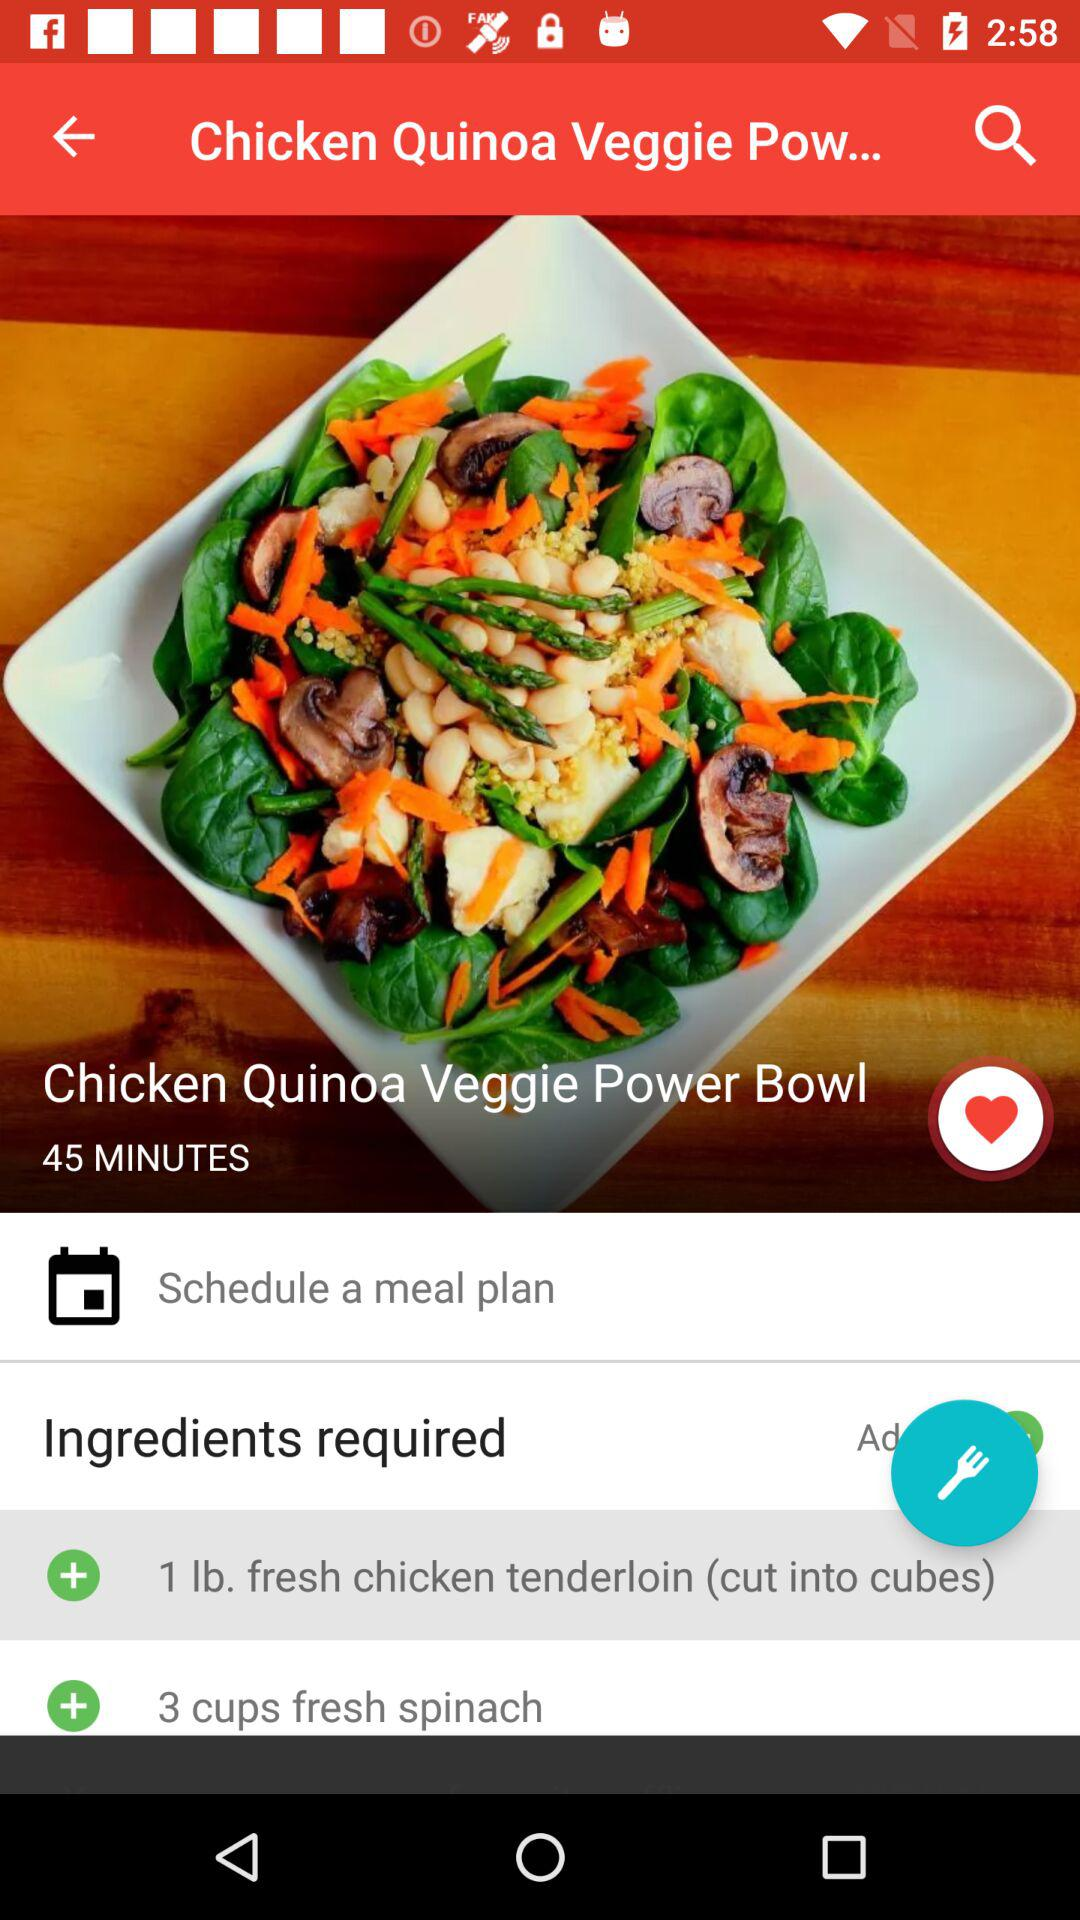What's the preparation time of the "Chicken Quinoa Veggie Power Bowl"? The preparation time is 45 minutes. 